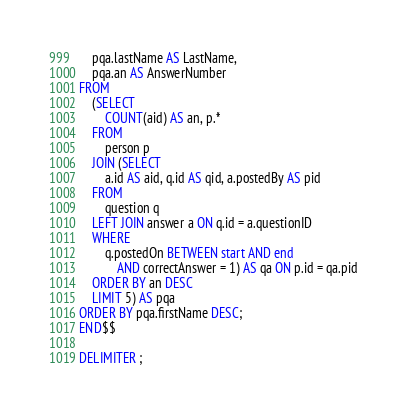<code> <loc_0><loc_0><loc_500><loc_500><_SQL_>    pqa.lastName AS LastName,
    pqa.an AS AnswerNumber
FROM
    (SELECT 
        COUNT(aid) AS an, p.*
    FROM
        person p
    JOIN (SELECT 
        a.id AS aid, q.id AS qid, a.postedBy AS pid
    FROM
        question q
    LEFT JOIN answer a ON q.id = a.questionID
    WHERE
        q.postedOn BETWEEN start AND end
            AND correctAnswer = 1) AS qa ON p.id = qa.pid
    ORDER BY an DESC
    LIMIT 5) AS pqa
ORDER BY pqa.firstName DESC;
END$$

DELIMITER ;
</code> 